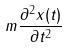<formula> <loc_0><loc_0><loc_500><loc_500>m \frac { \partial ^ { 2 } x ( t ) } { \partial t ^ { 2 } }</formula> 